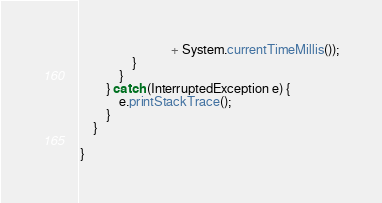Convert code to text. <code><loc_0><loc_0><loc_500><loc_500><_Java_>							+ System.currentTimeMillis());
				}
			}
		} catch (InterruptedException e) {
			e.printStackTrace();
		}
	}

}</code> 